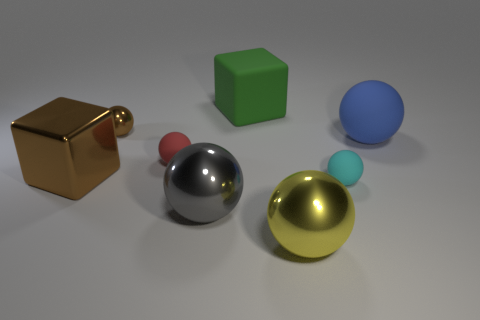Imagine these objects were part of a game, what could be the rules? In the hypothetical game, each color and shape could represent different elements or players. For example, the reflective objects might be 'collectors' that can 'gather' the matte objects. The goal could be to strategically move the spheres to gain points, with the large silver sphere having the power to change the position of other objects, the golden-yellow sphere acting as a multiplier, and the matte objects serving as points to be collected by the reflective ones. 